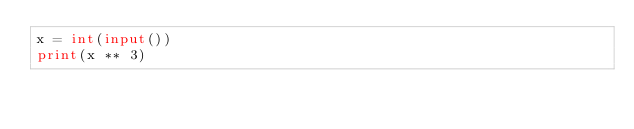<code> <loc_0><loc_0><loc_500><loc_500><_Python_>x = int(input())
print(x ** 3)</code> 